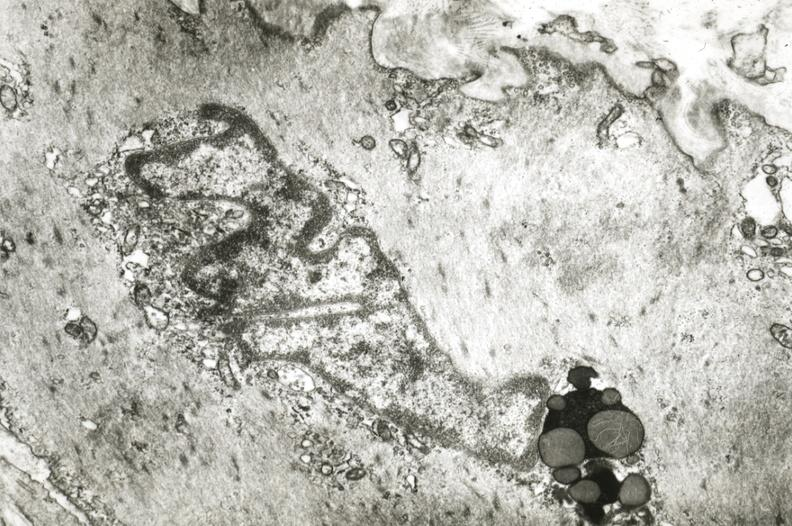does tuberculosis show intimal smooth muscle cell with lipochrome pigment?
Answer the question using a single word or phrase. No 